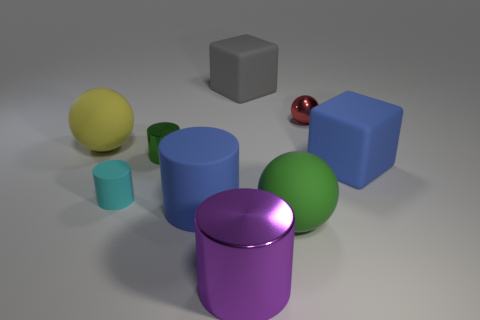Are the cube that is in front of the gray cube and the tiny red ball made of the same material?
Your answer should be compact. No. What number of things are metallic balls or big blue rubber cylinders that are right of the cyan cylinder?
Offer a terse response. 2. There is another cylinder that is the same material as the big blue cylinder; what color is it?
Provide a succinct answer. Cyan. How many purple cylinders are made of the same material as the big blue cylinder?
Make the answer very short. 0. What number of small cyan cylinders are there?
Make the answer very short. 1. Is the color of the matte cube in front of the tiny red object the same as the big cylinder that is left of the purple metal object?
Your answer should be very brief. Yes. What number of large rubber blocks are to the right of the big green sphere?
Your response must be concise. 1. What is the material of the ball that is the same color as the small shiny cylinder?
Offer a terse response. Rubber. Are there any gray things of the same shape as the cyan rubber object?
Your answer should be very brief. No. Is the material of the blue thing left of the small red sphere the same as the tiny object that is on the right side of the large purple cylinder?
Ensure brevity in your answer.  No. 